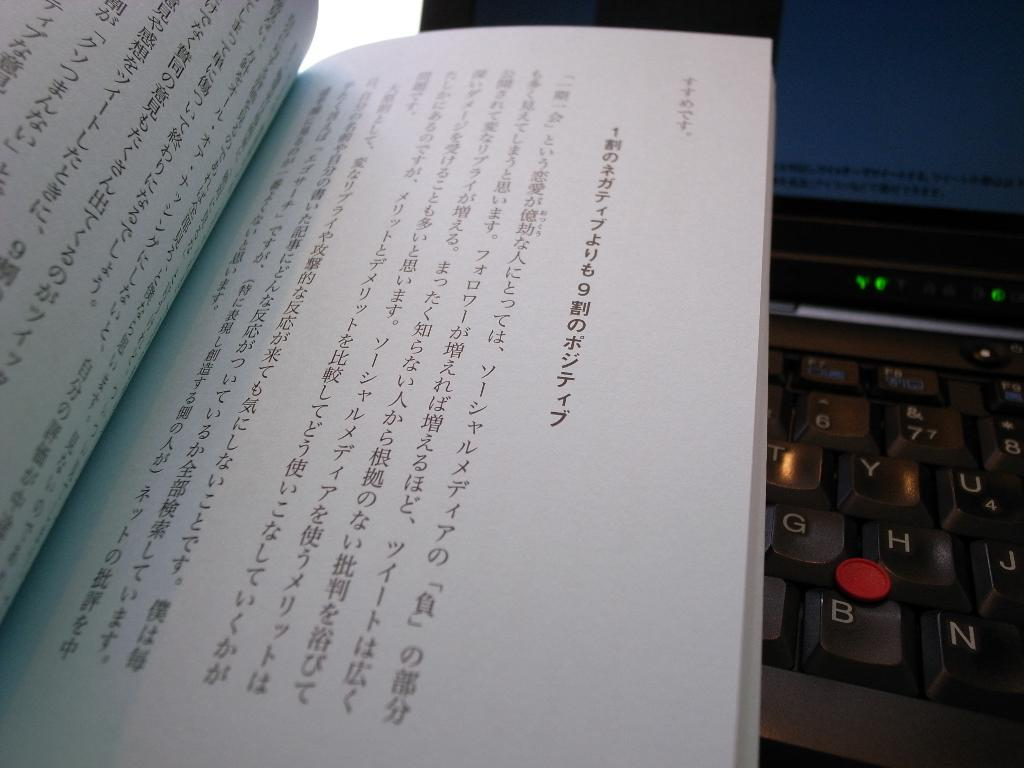<image>
Present a compact description of the photo's key features. a page in chinese on top of a keyboard by the letter g 